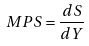<formula> <loc_0><loc_0><loc_500><loc_500>M P S = \frac { d S } { d Y }</formula> 